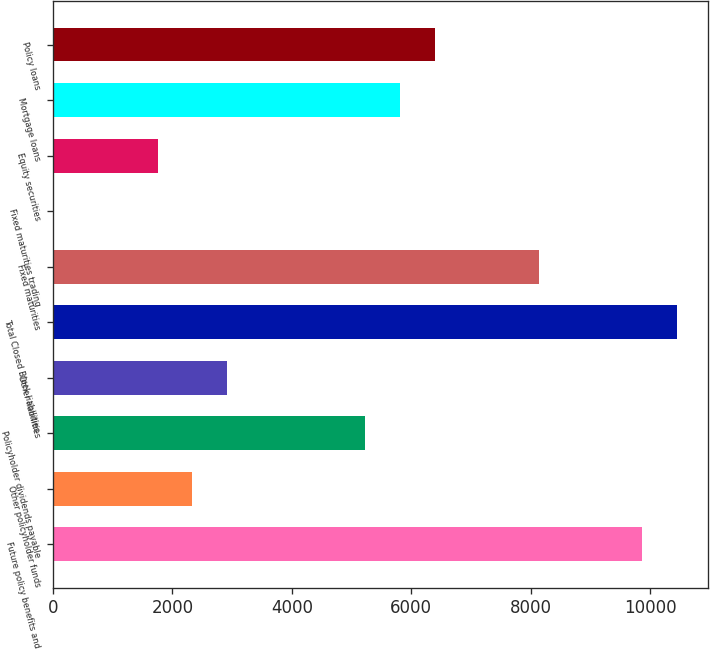<chart> <loc_0><loc_0><loc_500><loc_500><bar_chart><fcel>Future policy benefits and<fcel>Other policyholder funds<fcel>Policyholder dividends payable<fcel>Other liabilities<fcel>Total Closed Block liabilities<fcel>Fixed maturities<fcel>Fixed maturities trading<fcel>Equity securities<fcel>Mortgage loans<fcel>Policy loans<nl><fcel>9871.56<fcel>2330.52<fcel>5230.92<fcel>2910.6<fcel>10451.6<fcel>8131.32<fcel>10.2<fcel>1750.44<fcel>5811<fcel>6391.08<nl></chart> 